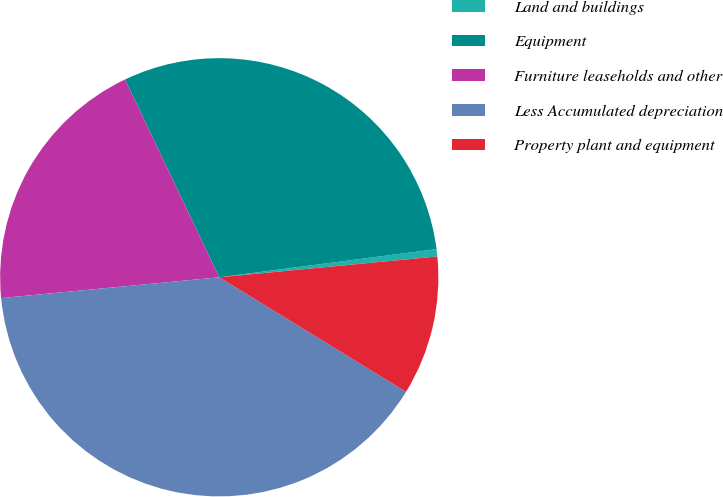<chart> <loc_0><loc_0><loc_500><loc_500><pie_chart><fcel>Land and buildings<fcel>Equipment<fcel>Furniture leaseholds and other<fcel>Less Accumulated depreciation<fcel>Property plant and equipment<nl><fcel>0.54%<fcel>30.02%<fcel>19.44%<fcel>39.73%<fcel>10.27%<nl></chart> 